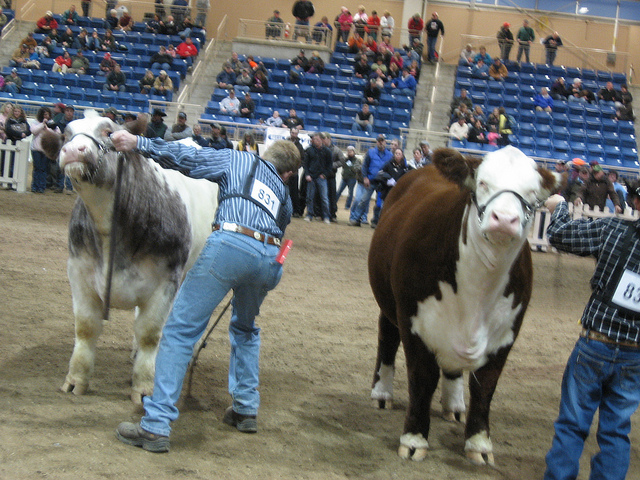<image>What animal is the boy riding? The boy is not riding an animal. However, it can be a horse, cow, or bull if there was. What animal is the boy riding? It is ambiguous what animal the boy is riding. It can be a horse, cow, or bull. 